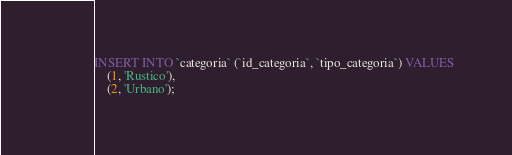Convert code to text. <code><loc_0><loc_0><loc_500><loc_500><_SQL_>INSERT INTO `categoria` (`id_categoria`, `tipo_categoria`) VALUES
	(1, 'Rustico'),
	(2, 'Urbano');
</code> 